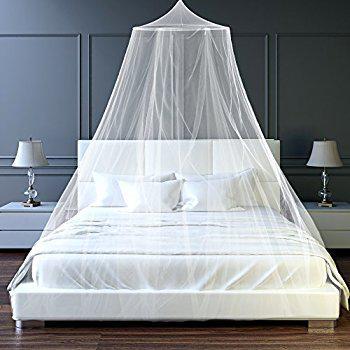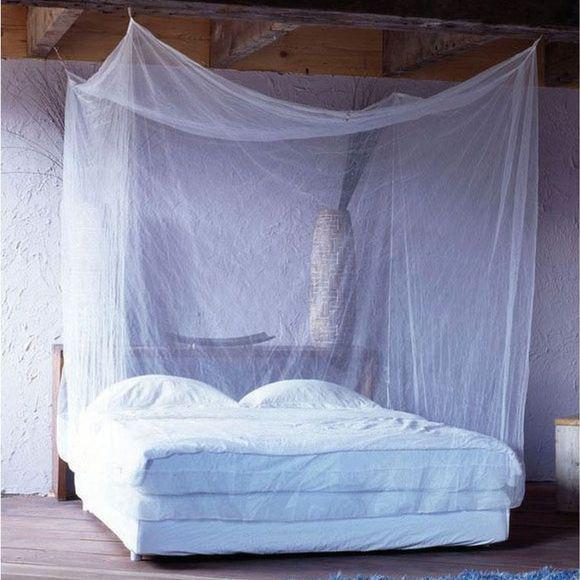The first image is the image on the left, the second image is the image on the right. Evaluate the accuracy of this statement regarding the images: "There are two beds.". Is it true? Answer yes or no. Yes. The first image is the image on the left, the second image is the image on the right. Assess this claim about the two images: "There are two canopies that cover a mattress.". Correct or not? Answer yes or no. Yes. 